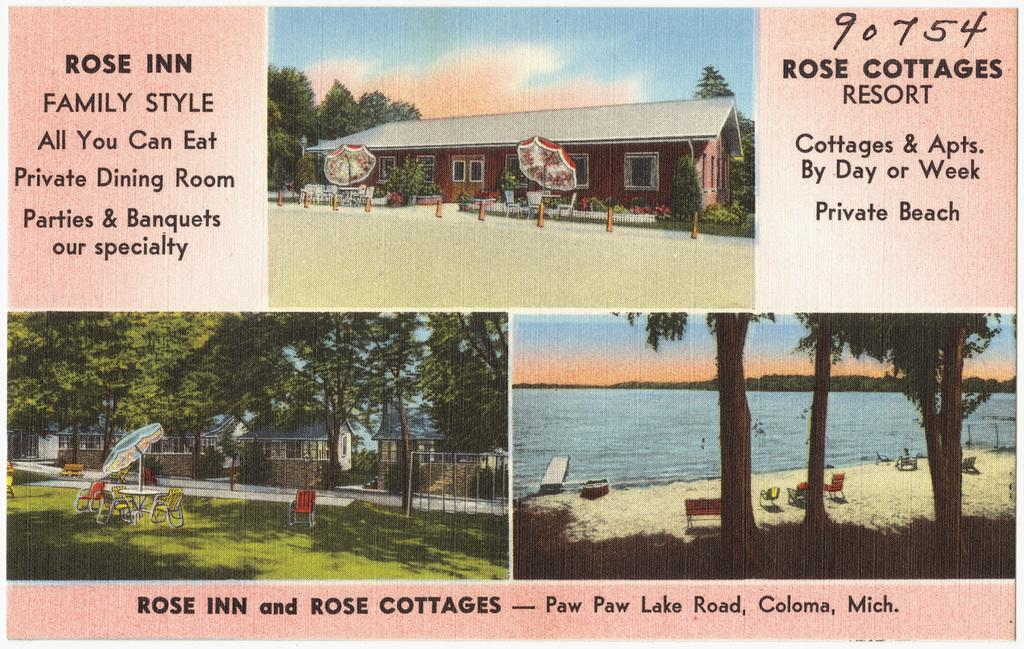What is the main subject of the poster in the image? The poster features a cottage resort. What type of images can be seen on the poster? The poster includes images of the resort. Is there any text on the poster? Yes, there is text on the poster. What type of sugar is being offered at the resort in the image? There is no mention of sugar or any offer in the image; it only features a poster of a cottage resort. What topics are being discussed in the image? There is no discussion or conversation depicted in the image; it only features a poster of a cottage resort. 